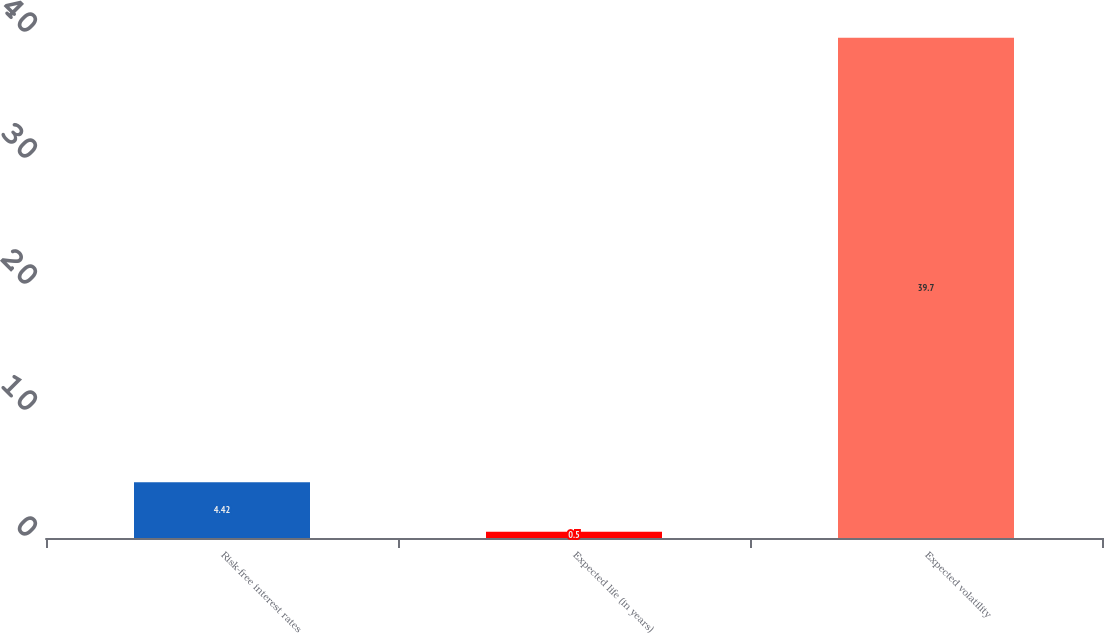<chart> <loc_0><loc_0><loc_500><loc_500><bar_chart><fcel>Risk-free interest rates<fcel>Expected life (in years)<fcel>Expected volatility<nl><fcel>4.42<fcel>0.5<fcel>39.7<nl></chart> 